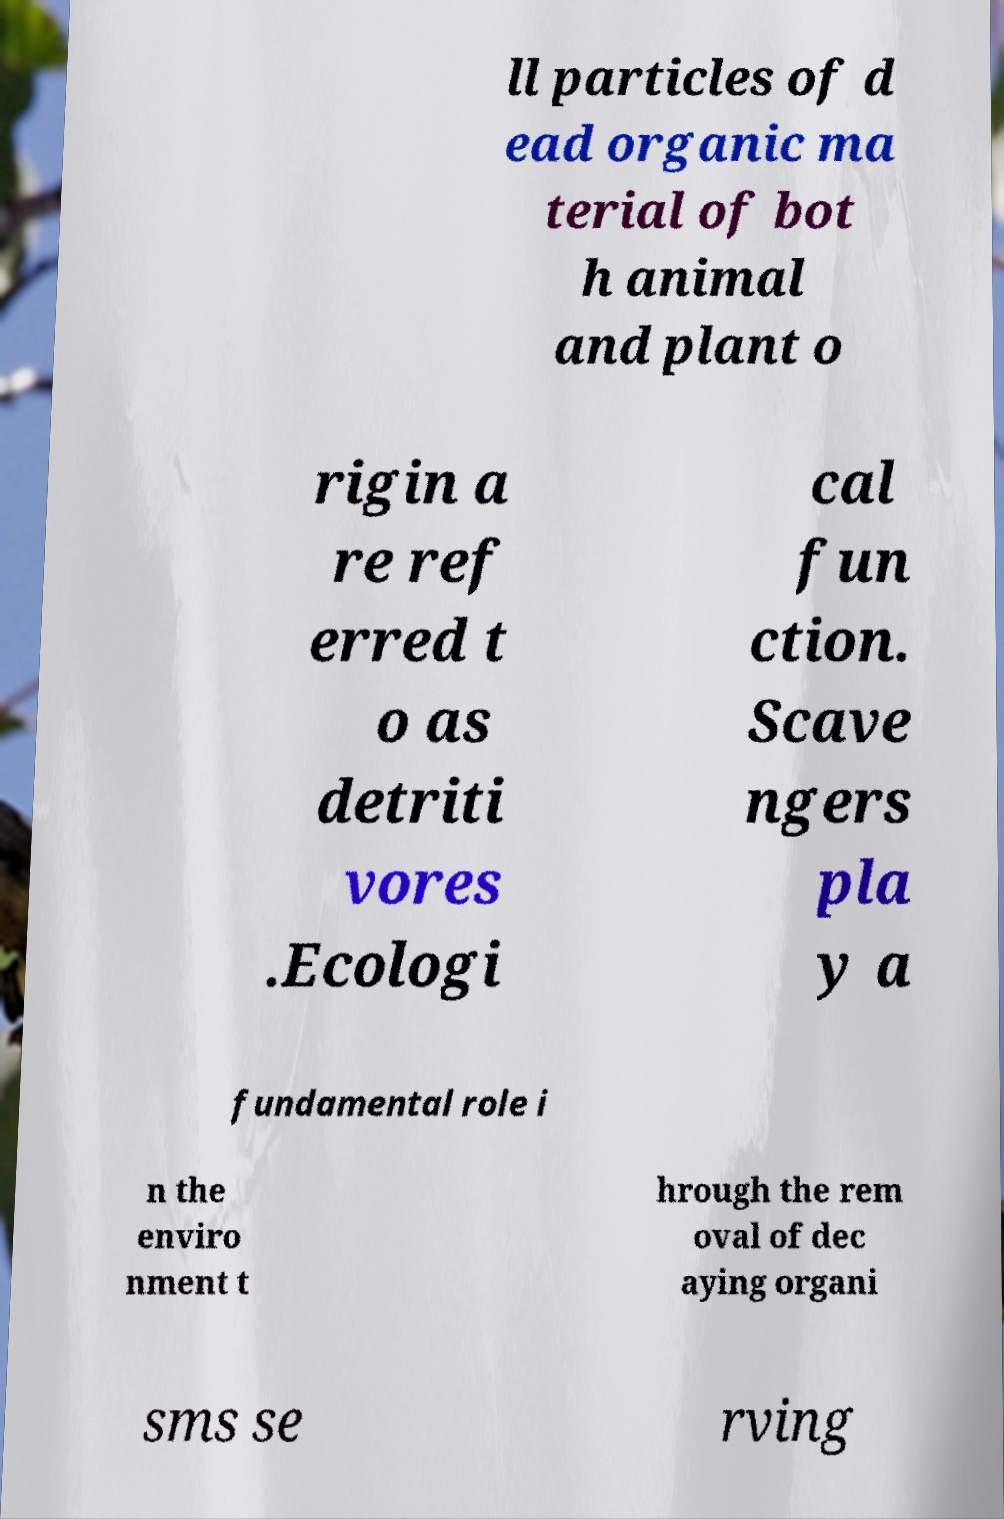Can you accurately transcribe the text from the provided image for me? ll particles of d ead organic ma terial of bot h animal and plant o rigin a re ref erred t o as detriti vores .Ecologi cal fun ction. Scave ngers pla y a fundamental role i n the enviro nment t hrough the rem oval of dec aying organi sms se rving 